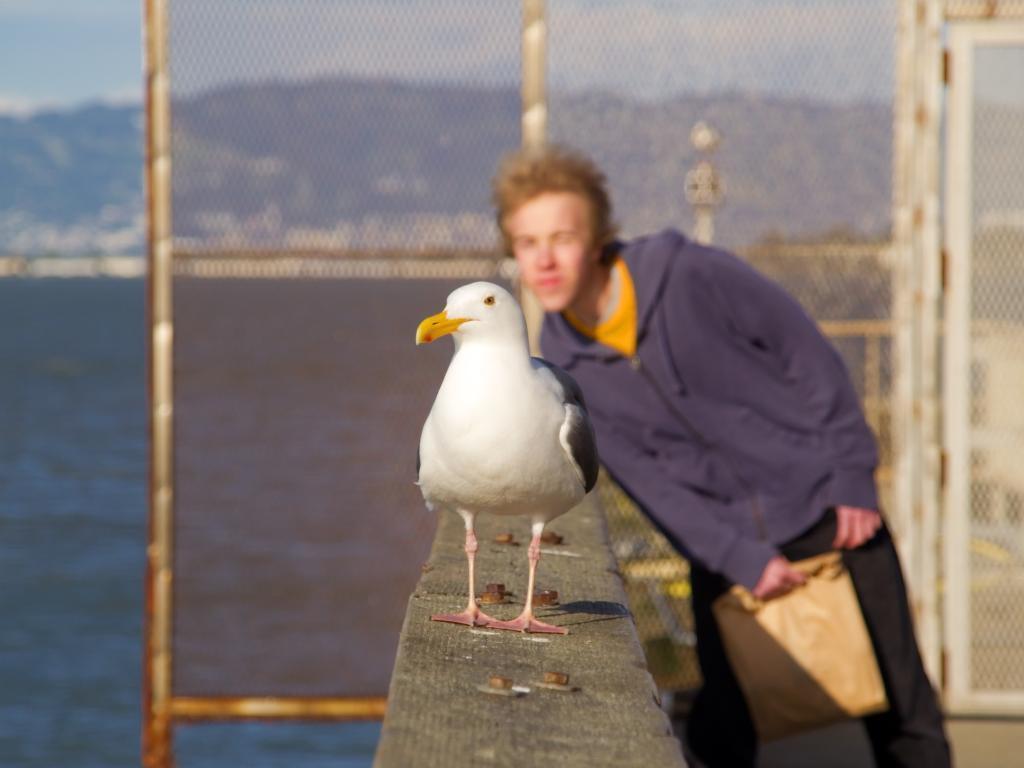Please provide a concise description of this image. In this picture there is a bird in the center of the image on a boundary and there is a boy behind it and there is a net boundary, water and greenery in the background area of the image. 